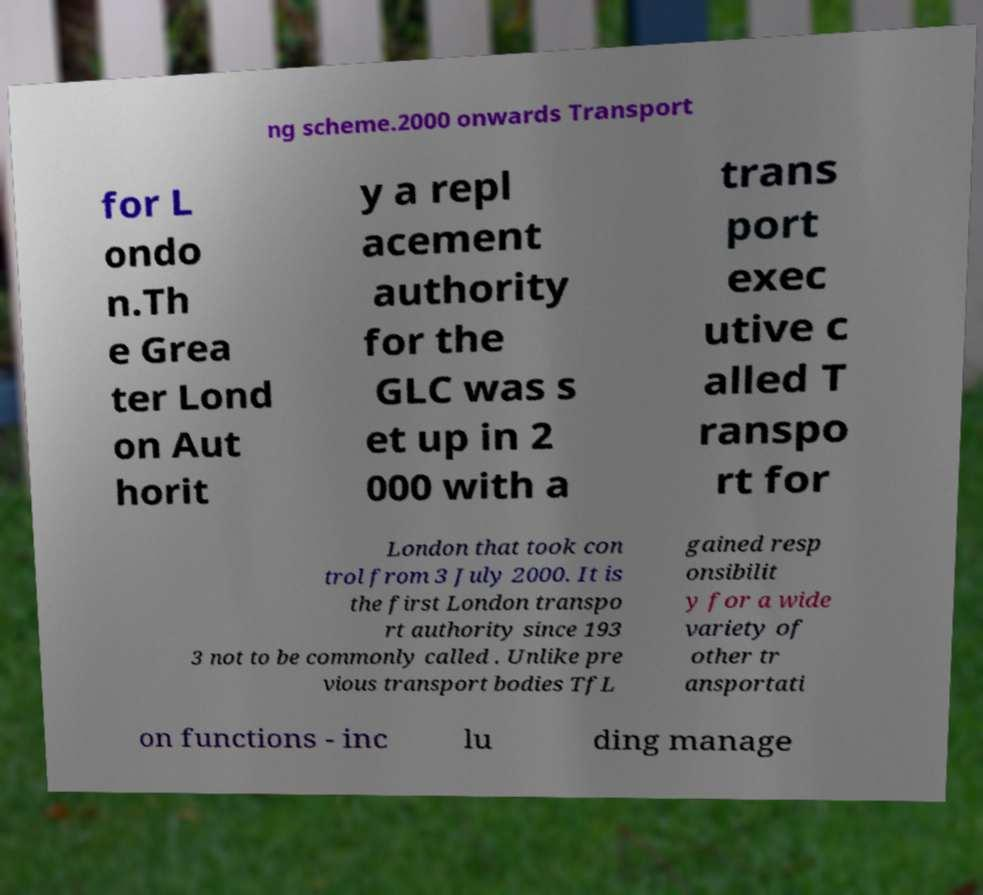Please read and relay the text visible in this image. What does it say? ng scheme.2000 onwards Transport for L ondo n.Th e Grea ter Lond on Aut horit y a repl acement authority for the GLC was s et up in 2 000 with a trans port exec utive c alled T ranspo rt for London that took con trol from 3 July 2000. It is the first London transpo rt authority since 193 3 not to be commonly called . Unlike pre vious transport bodies TfL gained resp onsibilit y for a wide variety of other tr ansportati on functions - inc lu ding manage 